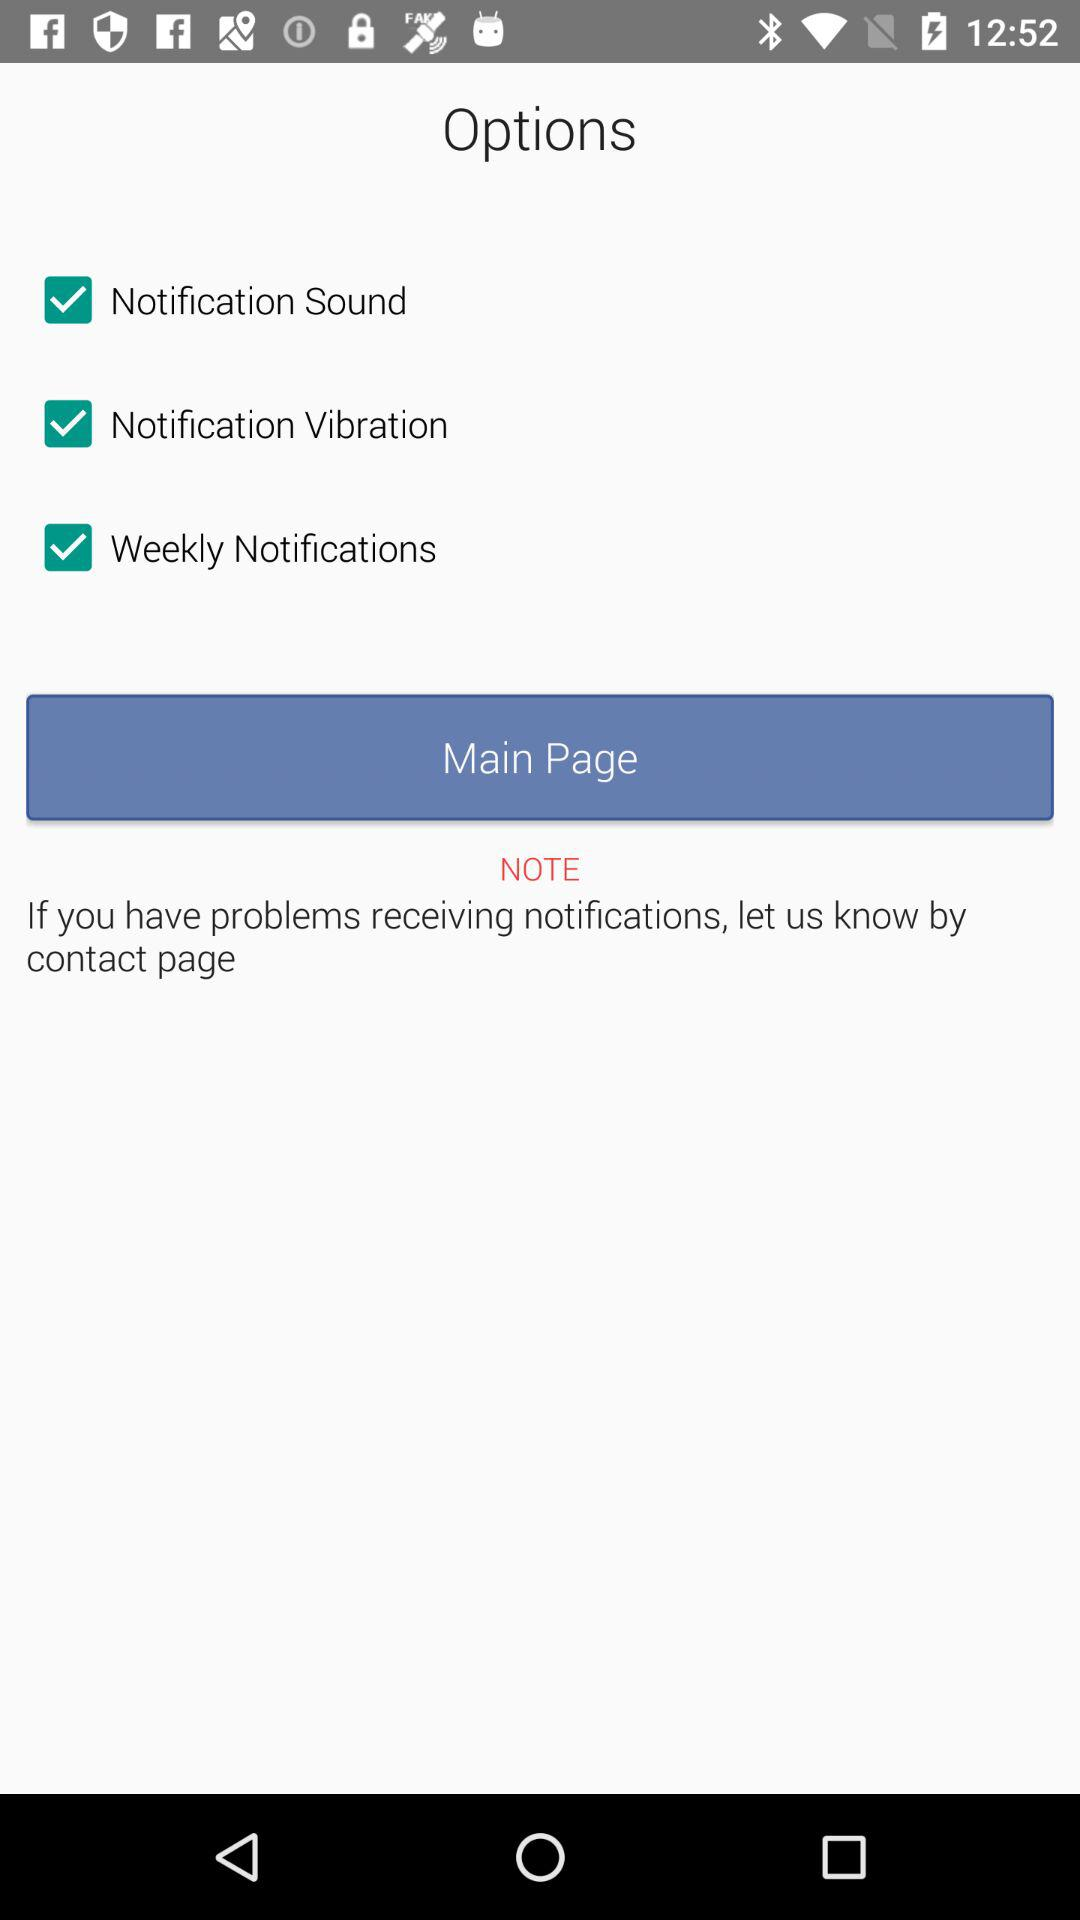What is the status of "Weekly Notification"? The status of "Weekly Notification" is "on". 